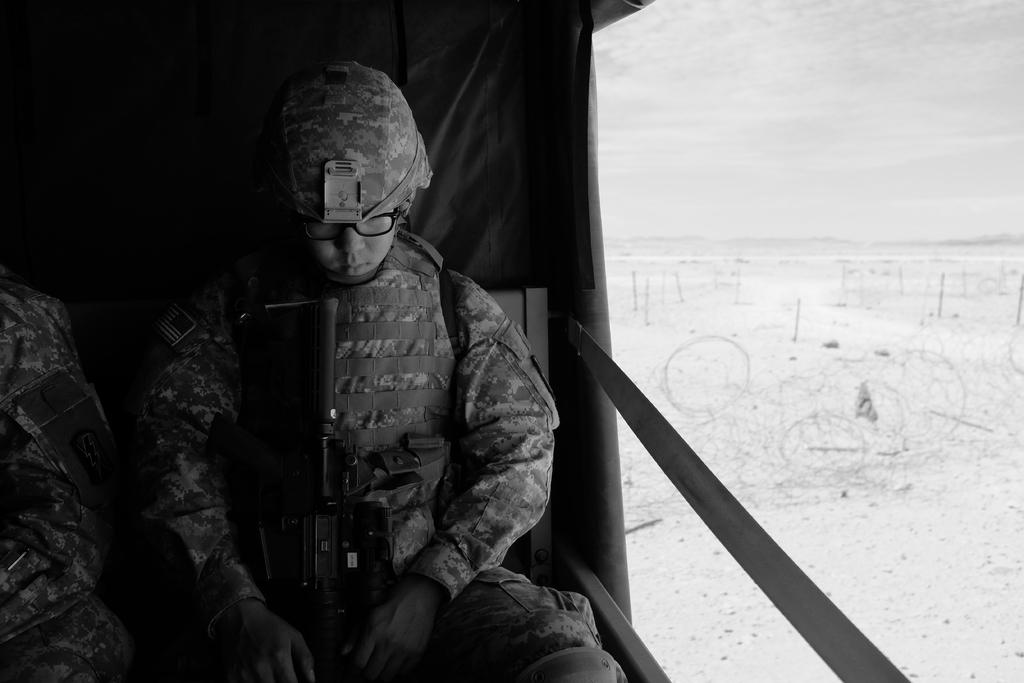What is the color scheme of the image? The image is black and white. What can be seen inside the vehicle in the image? There are two people sitting in a vehicle. What object is present in the image that could be used for protection or defense? There is a weapon in the image. What part of the natural environment is visible in the image? The sky is visible in the image. How many horses can be seen grazing in the image? There are no horses present in the image. What type of breath does the toad in the image have? There is no toad present in the image. 